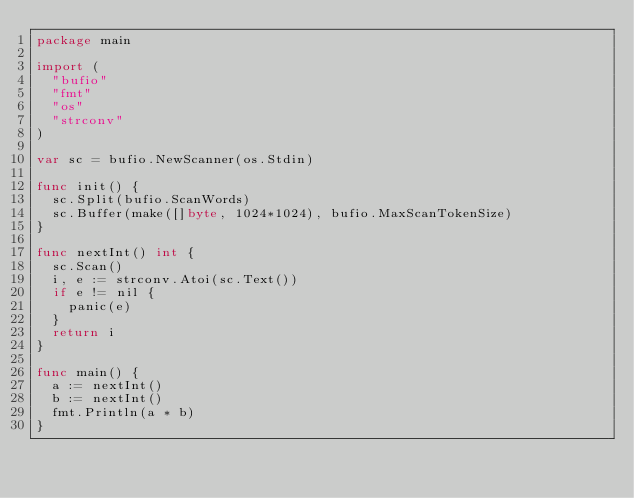Convert code to text. <code><loc_0><loc_0><loc_500><loc_500><_Go_>package main

import (
	"bufio"
	"fmt"
	"os"
	"strconv"
)

var sc = bufio.NewScanner(os.Stdin)

func init() {
	sc.Split(bufio.ScanWords)
	sc.Buffer(make([]byte, 1024*1024), bufio.MaxScanTokenSize)
}

func nextInt() int {
	sc.Scan()
	i, e := strconv.Atoi(sc.Text())
	if e != nil {
		panic(e)
	}
	return i
}

func main() {
	a := nextInt()
	b := nextInt()
	fmt.Println(a * b)
}
</code> 